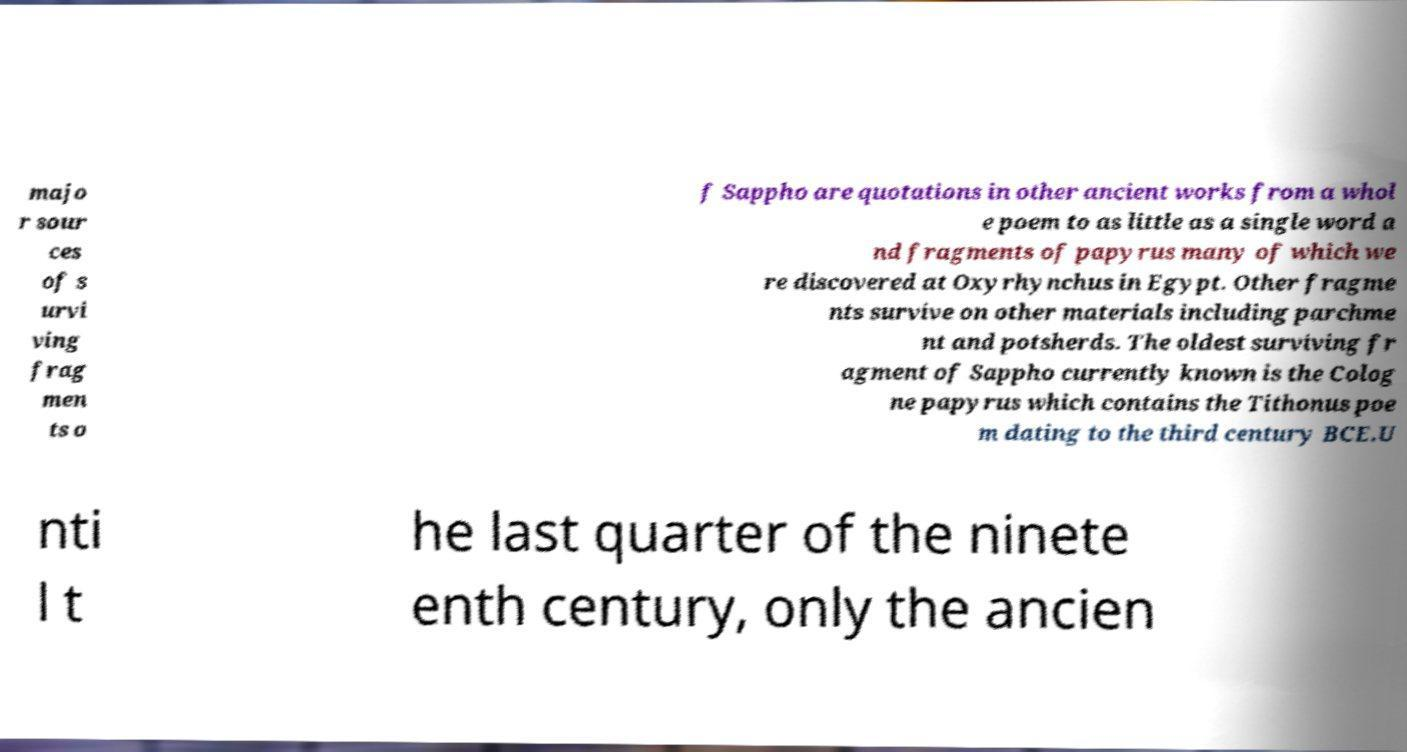Please identify and transcribe the text found in this image. majo r sour ces of s urvi ving frag men ts o f Sappho are quotations in other ancient works from a whol e poem to as little as a single word a nd fragments of papyrus many of which we re discovered at Oxyrhynchus in Egypt. Other fragme nts survive on other materials including parchme nt and potsherds. The oldest surviving fr agment of Sappho currently known is the Colog ne papyrus which contains the Tithonus poe m dating to the third century BCE.U nti l t he last quarter of the ninete enth century, only the ancien 